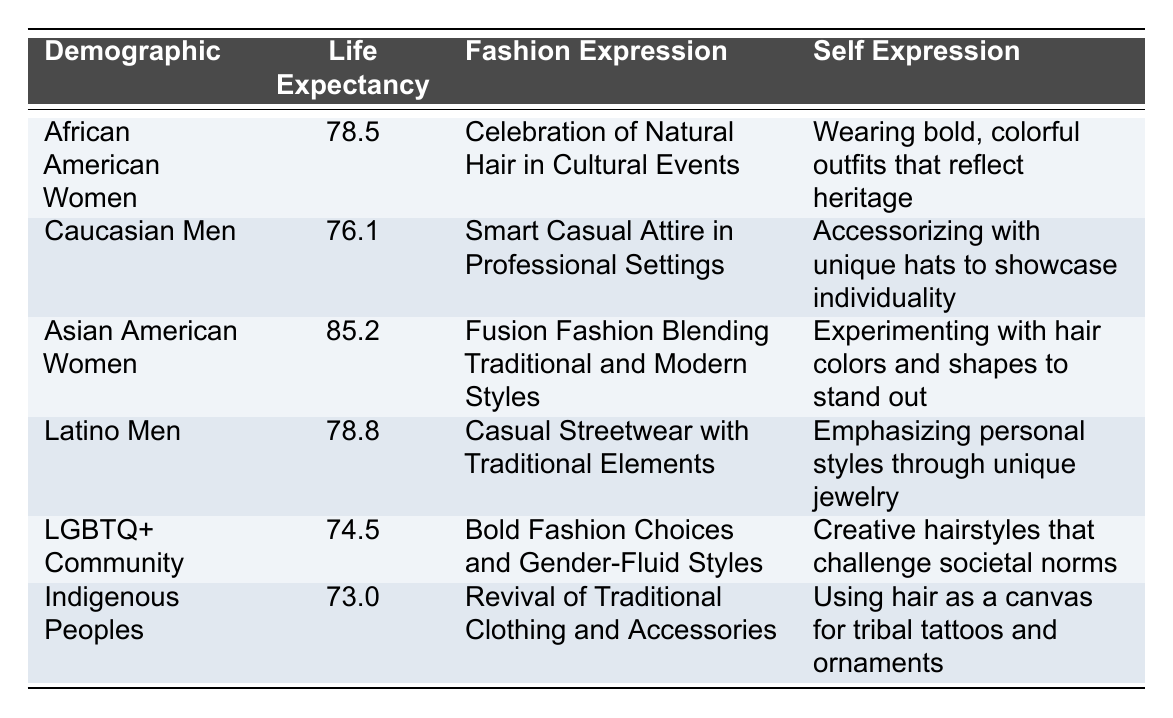What is the life expectancy of Asian American women? The table lists the life expectancy of Asian American women as 85.2 years.
Answer: 85.2 Which demographic has the highest life expectancy? To find this, we compare the life expectancy values in the table: African American Women (78.5), Caucasian Men (76.1), Asian American Women (85.2), Latino Men (78.8), LGBTQ+ Community (74.5), and Indigenous Peoples (73.0). Asian American Women has the highest value at 85.2.
Answer: Asian American Women Is the fashion expression of LGBTQ+ Community characterized by bold choices? The table describes the fashion expression of the LGBTQ+ Community as "Bold Fashion Choices and Gender-Fluid Styles," confirming that it is indeed characterized by bold choices.
Answer: Yes What is the difference in life expectancy between Latino Men and Indigenous Peoples? The life expectancy of Latino Men is 78.8 years, and Indigenous Peoples is 73.0 years. The difference can be calculated as 78.8 - 73.0 = 5.8 years.
Answer: 5.8 Are casual streetwear and traditional elements part of Latino Men’s fashion expression? The table specifies that Latino Men's fashion expression includes "Casual Streetwear with Traditional Elements," thereby confirming this fact.
Answer: Yes What is the average life expectancy of the demographics listed in the table? To find the average, we need to sum the life expectancies: 78.5 + 76.1 + 85.2 + 78.8 + 74.5 + 73.0 = 466.1. There are 6 demographics, so the average is 466.1 / 6 = 77.68.
Answer: 77.68 Which demographic emphasizes personal styles through unique jewelry? Referring to the table, Latino Men are listed under "SelfExpression" as emphasizing personal styles through unique jewelry.
Answer: Latino Men Is there a demographic with a life expectancy below 75 years? Yes, the table shows that both the LGBTQ+ Community (74.5) and Indigenous Peoples (73.0) have life expectancies below 75 years.
Answer: Yes 